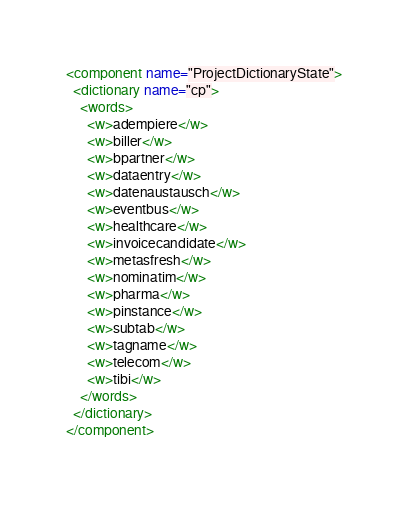<code> <loc_0><loc_0><loc_500><loc_500><_XML_><component name="ProjectDictionaryState">
  <dictionary name="cp">
    <words>
      <w>adempiere</w>
      <w>biller</w>
      <w>bpartner</w>
      <w>dataentry</w>
      <w>datenaustausch</w>
      <w>eventbus</w>
      <w>healthcare</w>
      <w>invoicecandidate</w>
      <w>metasfresh</w>
      <w>nominatim</w>
      <w>pharma</w>
      <w>pinstance</w>
      <w>subtab</w>
      <w>tagname</w>
      <w>telecom</w>
      <w>tibi</w>
    </words>
  </dictionary>
</component></code> 